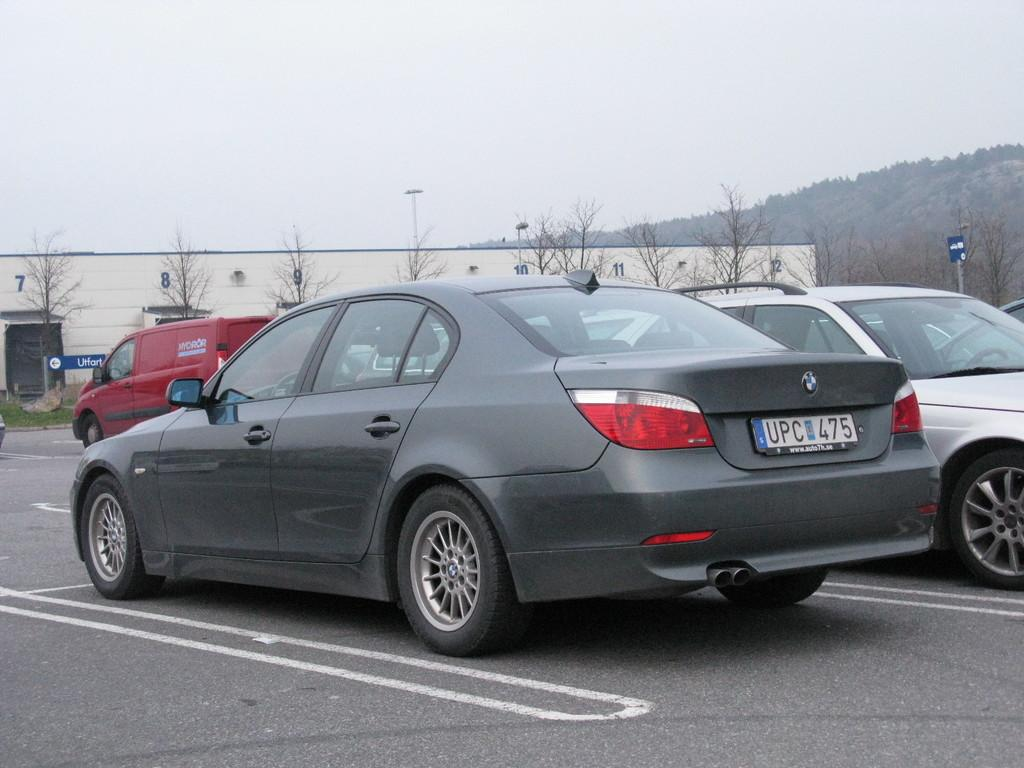What is happening on the road in the image? There are vehicles on the road in the image. What can be seen behind the vehicles? There is a building, trees, and poles visible behind the vehicles. What is the landscape like in the background of the image? There is a hill and the sky visible in the background of the image. What type of wood can be seen on the vehicles' lips in the image? There are no vehicles with lips in the image, and therefore no wood can be seen on them. 